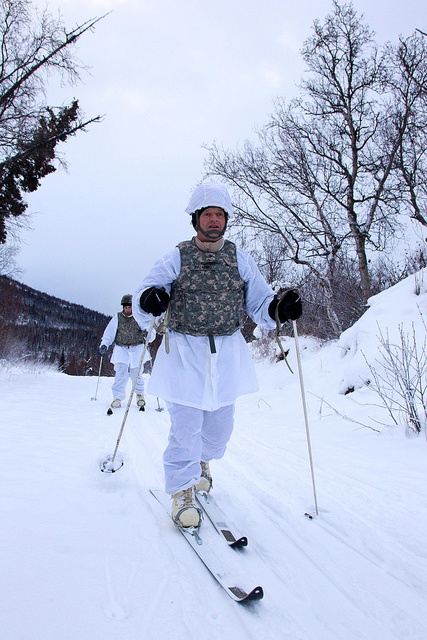Describe the objects in this image and their specific colors. I can see people in darkgray, lavender, gray, and black tones, people in darkgray, lavender, and gray tones, skis in darkgray, lavender, and black tones, and skis in darkgray, black, lavender, and gray tones in this image. 